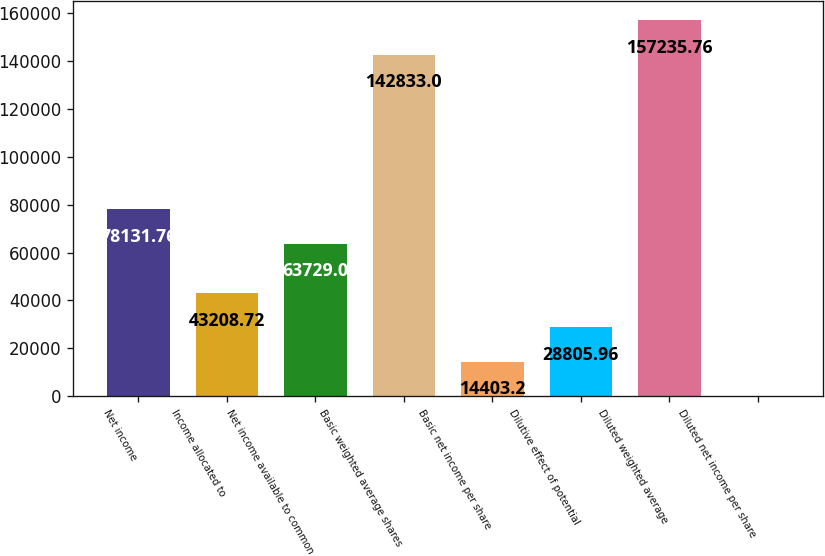<chart> <loc_0><loc_0><loc_500><loc_500><bar_chart><fcel>Net income<fcel>Income allocated to<fcel>Net income available to common<fcel>Basic weighted average shares<fcel>Basic net income per share<fcel>Dilutive effect of potential<fcel>Diluted weighted average<fcel>Diluted net income per share<nl><fcel>78131.8<fcel>43208.7<fcel>63729<fcel>142833<fcel>14403.2<fcel>28806<fcel>157236<fcel>0.44<nl></chart> 